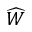Convert formula to latex. <formula><loc_0><loc_0><loc_500><loc_500>\widehat { W }</formula> 